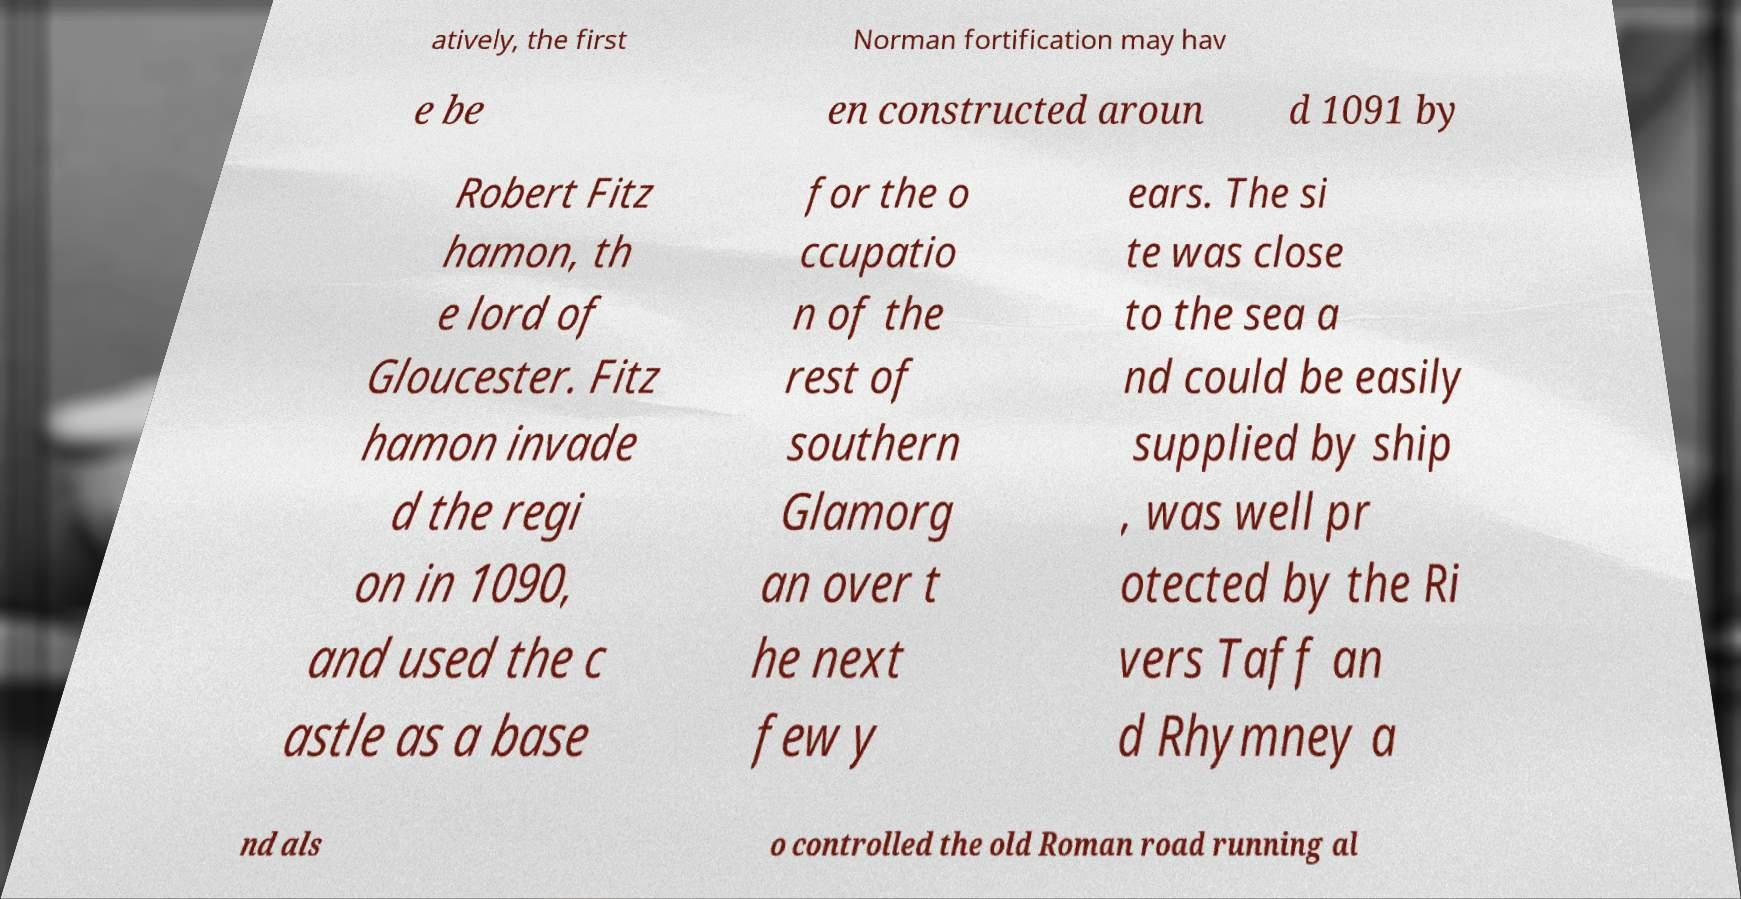Can you accurately transcribe the text from the provided image for me? atively, the first Norman fortification may hav e be en constructed aroun d 1091 by Robert Fitz hamon, th e lord of Gloucester. Fitz hamon invade d the regi on in 1090, and used the c astle as a base for the o ccupatio n of the rest of southern Glamorg an over t he next few y ears. The si te was close to the sea a nd could be easily supplied by ship , was well pr otected by the Ri vers Taff an d Rhymney a nd als o controlled the old Roman road running al 